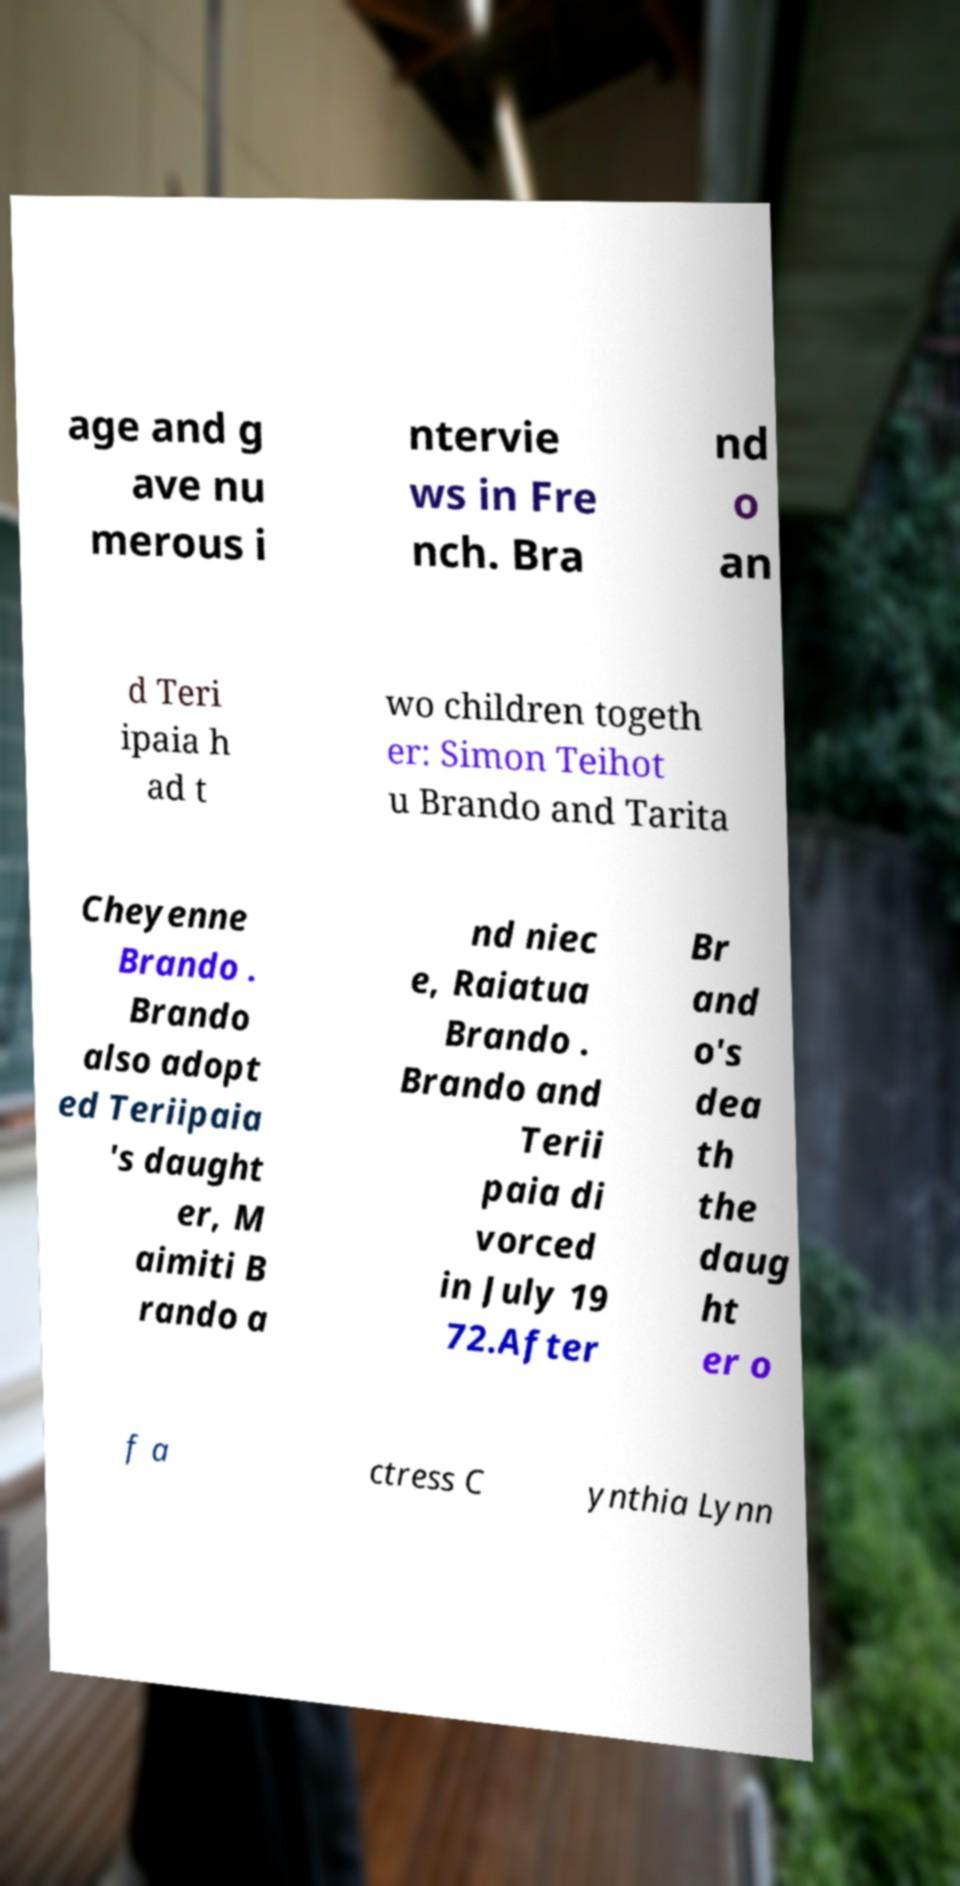Can you accurately transcribe the text from the provided image for me? age and g ave nu merous i ntervie ws in Fre nch. Bra nd o an d Teri ipaia h ad t wo children togeth er: Simon Teihot u Brando and Tarita Cheyenne Brando . Brando also adopt ed Teriipaia 's daught er, M aimiti B rando a nd niec e, Raiatua Brando . Brando and Terii paia di vorced in July 19 72.After Br and o's dea th the daug ht er o f a ctress C ynthia Lynn 